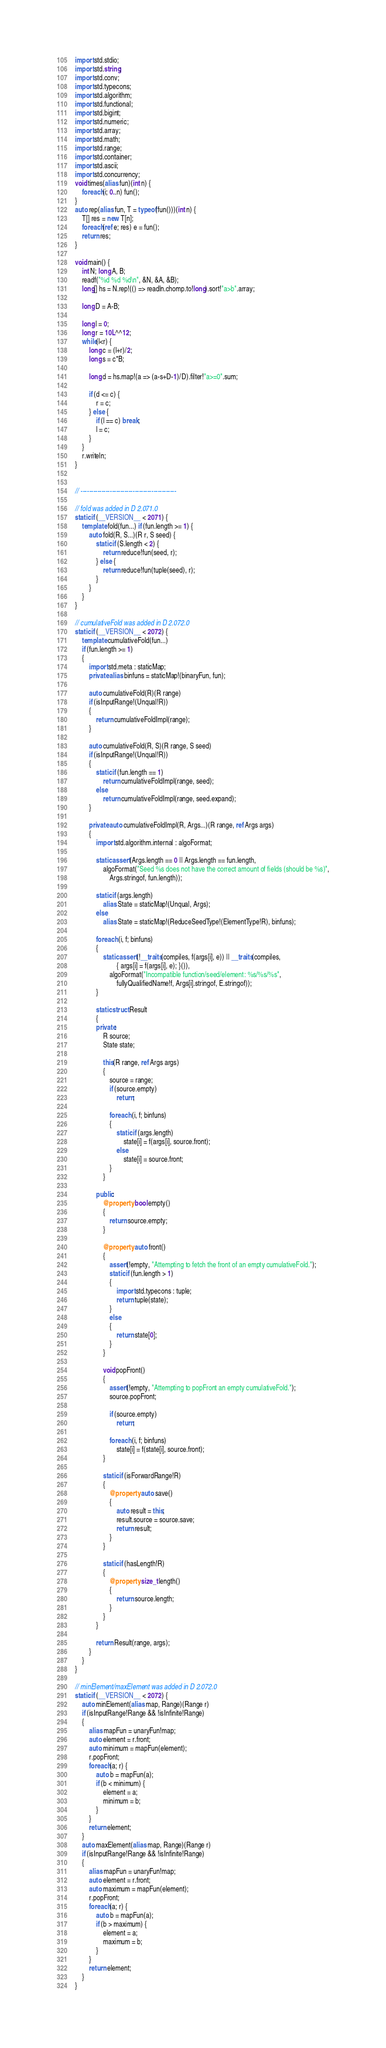<code> <loc_0><loc_0><loc_500><loc_500><_D_>import std.stdio;
import std.string;
import std.conv;
import std.typecons;
import std.algorithm;
import std.functional;
import std.bigint;
import std.numeric;
import std.array;
import std.math;
import std.range;
import std.container;
import std.ascii;
import std.concurrency;
void times(alias fun)(int n) {
    foreach(i; 0..n) fun();
}
auto rep(alias fun, T = typeof(fun()))(int n) {
    T[] res = new T[n];
    foreach(ref e; res) e = fun();
    return res;
}

void main() {
    int N; long A, B;
    readf("%d %d %d\n", &N, &A, &B);
    long[] hs = N.rep!(() => readln.chomp.to!long).sort!"a>b".array;

    long D = A-B;

    long l = 0;
    long r = 10L^^12;
    while(l<r) {
        long c = (l+r)/2;
        long s = c*B;

        long d = hs.map!(a => (a-s+D-1)/D).filter!"a>=0".sum;

        if (d <= c) {
            r = c;
        } else {
            if (l == c) break;
            l = c;
        }
    }
    r.writeln;
}


// ----------------------------------------------

// fold was added in D 2.071.0
static if (__VERSION__ < 2071) {
    template fold(fun...) if (fun.length >= 1) {
        auto fold(R, S...)(R r, S seed) {
            static if (S.length < 2) {
                return reduce!fun(seed, r);
            } else {
                return reduce!fun(tuple(seed), r);
            }
        }
    }
}

// cumulativeFold was added in D 2.072.0
static if (__VERSION__ < 2072) {
    template cumulativeFold(fun...)
    if (fun.length >= 1)
    {
        import std.meta : staticMap;
        private alias binfuns = staticMap!(binaryFun, fun);

        auto cumulativeFold(R)(R range)
        if (isInputRange!(Unqual!R))
        {
            return cumulativeFoldImpl(range);
        }

        auto cumulativeFold(R, S)(R range, S seed)
        if (isInputRange!(Unqual!R))
        {
            static if (fun.length == 1)
                return cumulativeFoldImpl(range, seed);
            else
                return cumulativeFoldImpl(range, seed.expand);
        }

        private auto cumulativeFoldImpl(R, Args...)(R range, ref Args args)
        {
            import std.algorithm.internal : algoFormat;

            static assert(Args.length == 0 || Args.length == fun.length,
                algoFormat("Seed %s does not have the correct amount of fields (should be %s)",
                    Args.stringof, fun.length));

            static if (args.length)
                alias State = staticMap!(Unqual, Args);
            else
                alias State = staticMap!(ReduceSeedType!(ElementType!R), binfuns);

            foreach (i, f; binfuns)
            {
                static assert(!__traits(compiles, f(args[i], e)) || __traits(compiles,
                        { args[i] = f(args[i], e); }()),
                    algoFormat("Incompatible function/seed/element: %s/%s/%s",
                        fullyQualifiedName!f, Args[i].stringof, E.stringof));
            }

            static struct Result
            {
            private:
                R source;
                State state;

                this(R range, ref Args args)
                {
                    source = range;
                    if (source.empty)
                        return;

                    foreach (i, f; binfuns)
                    {
                        static if (args.length)
                            state[i] = f(args[i], source.front);
                        else
                            state[i] = source.front;
                    }
                }

            public:
                @property bool empty()
                {
                    return source.empty;
                }

                @property auto front()
                {
                    assert(!empty, "Attempting to fetch the front of an empty cumulativeFold.");
                    static if (fun.length > 1)
                    {
                        import std.typecons : tuple;
                        return tuple(state);
                    }
                    else
                    {
                        return state[0];
                    }
                }

                void popFront()
                {
                    assert(!empty, "Attempting to popFront an empty cumulativeFold.");
                    source.popFront;

                    if (source.empty)
                        return;

                    foreach (i, f; binfuns)
                        state[i] = f(state[i], source.front);
                }

                static if (isForwardRange!R)
                {
                    @property auto save()
                    {
                        auto result = this;
                        result.source = source.save;
                        return result;
                    }
                }

                static if (hasLength!R)
                {
                    @property size_t length()
                    {
                        return source.length;
                    }
                }
            }

            return Result(range, args);
        }
    }
}

// minElement/maxElement was added in D 2.072.0
static if (__VERSION__ < 2072) {
    auto minElement(alias map, Range)(Range r)
    if (isInputRange!Range && !isInfinite!Range)
    {
        alias mapFun = unaryFun!map;
        auto element = r.front;
        auto minimum = mapFun(element);
        r.popFront;
        foreach(a; r) {
            auto b = mapFun(a);
            if (b < minimum) {
                element = a;
                minimum = b;
            }
        }
        return element;
    }
    auto maxElement(alias map, Range)(Range r)
    if (isInputRange!Range && !isInfinite!Range)
    {
        alias mapFun = unaryFun!map;
        auto element = r.front;
        auto maximum = mapFun(element);
        r.popFront;
        foreach(a; r) {
            auto b = mapFun(a);
            if (b > maximum) {
                element = a;
                maximum = b;
            }
        }
        return element;
    }
}
</code> 